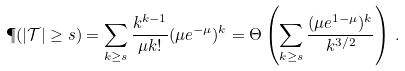Convert formula to latex. <formula><loc_0><loc_0><loc_500><loc_500>\P ( | \mathcal { T } | \geq s ) & = \sum _ { k \geq s } \frac { k ^ { k - 1 } } { \mu k ! } ( \mu e ^ { - \mu } ) ^ { k } = \Theta \left ( \sum _ { k \geq s } \frac { ( \mu e ^ { 1 - \mu } ) ^ { k } } { k ^ { 3 / 2 } } \right ) \, .</formula> 